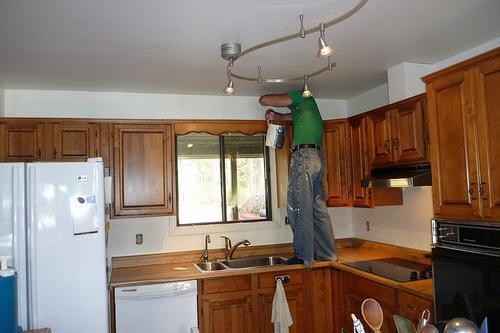How many people are in picture?
Give a very brief answer. 1. 